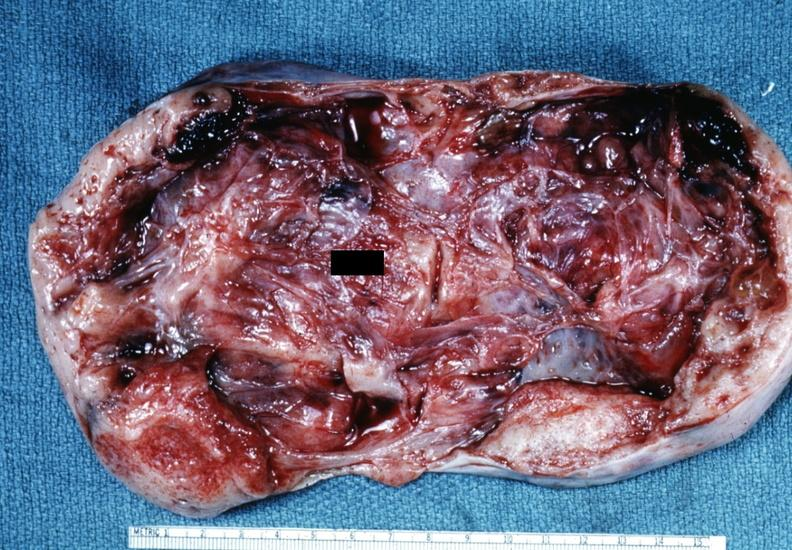s stillborn cord around neck present?
Answer the question using a single word or phrase. No 